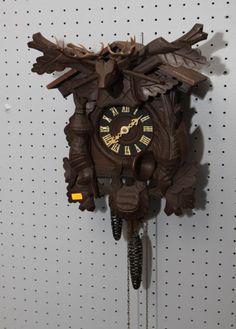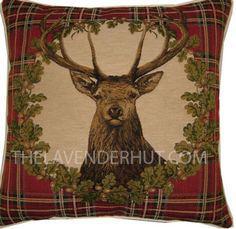The first image is the image on the left, the second image is the image on the right. For the images displayed, is the sentence "At least one object is made of wood." factually correct? Answer yes or no. Yes. 